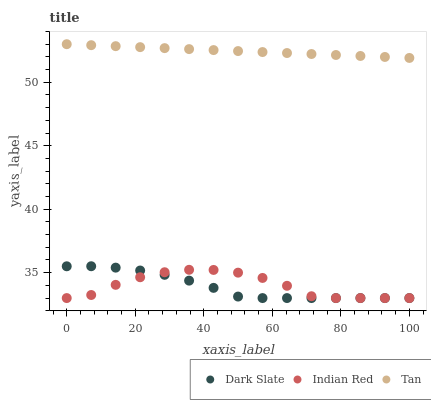Does Dark Slate have the minimum area under the curve?
Answer yes or no. Yes. Does Tan have the maximum area under the curve?
Answer yes or no. Yes. Does Indian Red have the minimum area under the curve?
Answer yes or no. No. Does Indian Red have the maximum area under the curve?
Answer yes or no. No. Is Tan the smoothest?
Answer yes or no. Yes. Is Indian Red the roughest?
Answer yes or no. Yes. Is Indian Red the smoothest?
Answer yes or no. No. Is Tan the roughest?
Answer yes or no. No. Does Dark Slate have the lowest value?
Answer yes or no. Yes. Does Tan have the lowest value?
Answer yes or no. No. Does Tan have the highest value?
Answer yes or no. Yes. Does Indian Red have the highest value?
Answer yes or no. No. Is Indian Red less than Tan?
Answer yes or no. Yes. Is Tan greater than Indian Red?
Answer yes or no. Yes. Does Dark Slate intersect Indian Red?
Answer yes or no. Yes. Is Dark Slate less than Indian Red?
Answer yes or no. No. Is Dark Slate greater than Indian Red?
Answer yes or no. No. Does Indian Red intersect Tan?
Answer yes or no. No. 